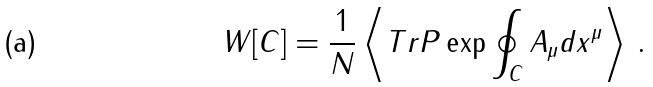<formula> <loc_0><loc_0><loc_500><loc_500>W [ C ] = \frac { 1 } { N } \left \langle T r P \exp \oint _ { C } A _ { \mu } d x ^ { \mu } \right \rangle \, .</formula> 